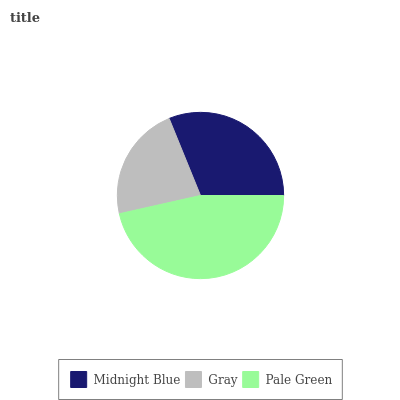Is Gray the minimum?
Answer yes or no. Yes. Is Pale Green the maximum?
Answer yes or no. Yes. Is Pale Green the minimum?
Answer yes or no. No. Is Gray the maximum?
Answer yes or no. No. Is Pale Green greater than Gray?
Answer yes or no. Yes. Is Gray less than Pale Green?
Answer yes or no. Yes. Is Gray greater than Pale Green?
Answer yes or no. No. Is Pale Green less than Gray?
Answer yes or no. No. Is Midnight Blue the high median?
Answer yes or no. Yes. Is Midnight Blue the low median?
Answer yes or no. Yes. Is Gray the high median?
Answer yes or no. No. Is Pale Green the low median?
Answer yes or no. No. 